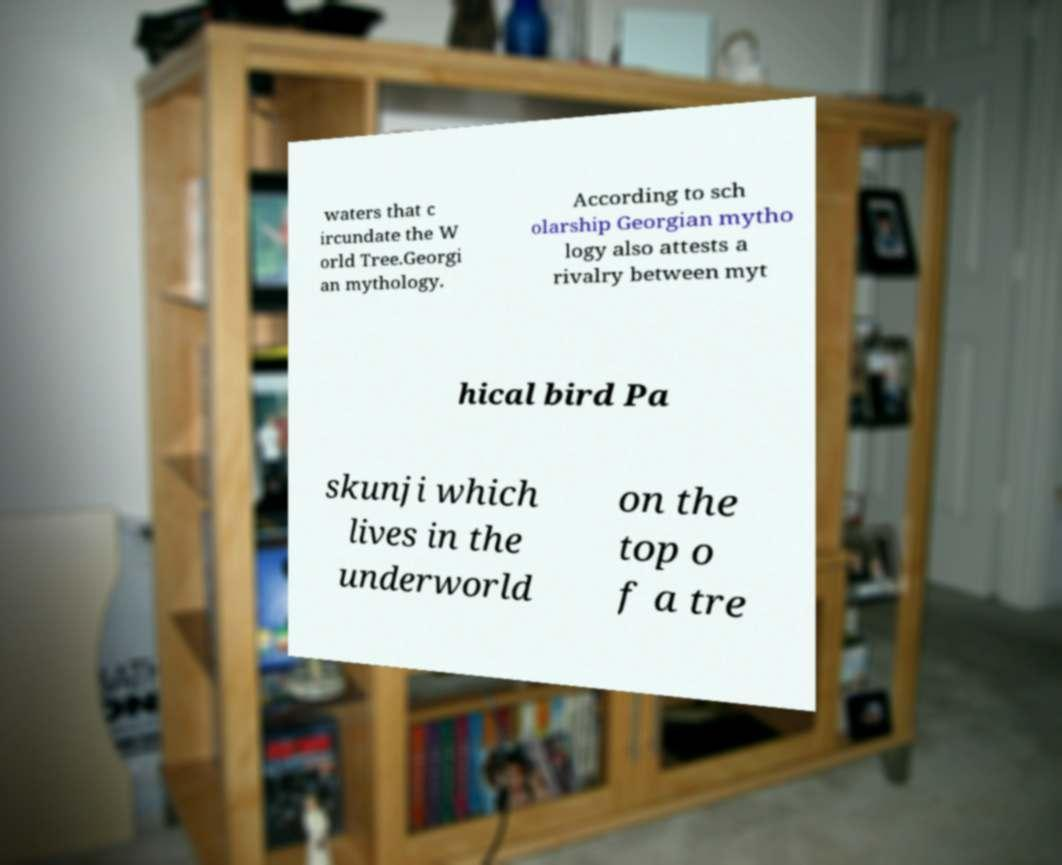What messages or text are displayed in this image? I need them in a readable, typed format. waters that c ircundate the W orld Tree.Georgi an mythology. According to sch olarship Georgian mytho logy also attests a rivalry between myt hical bird Pa skunji which lives in the underworld on the top o f a tre 